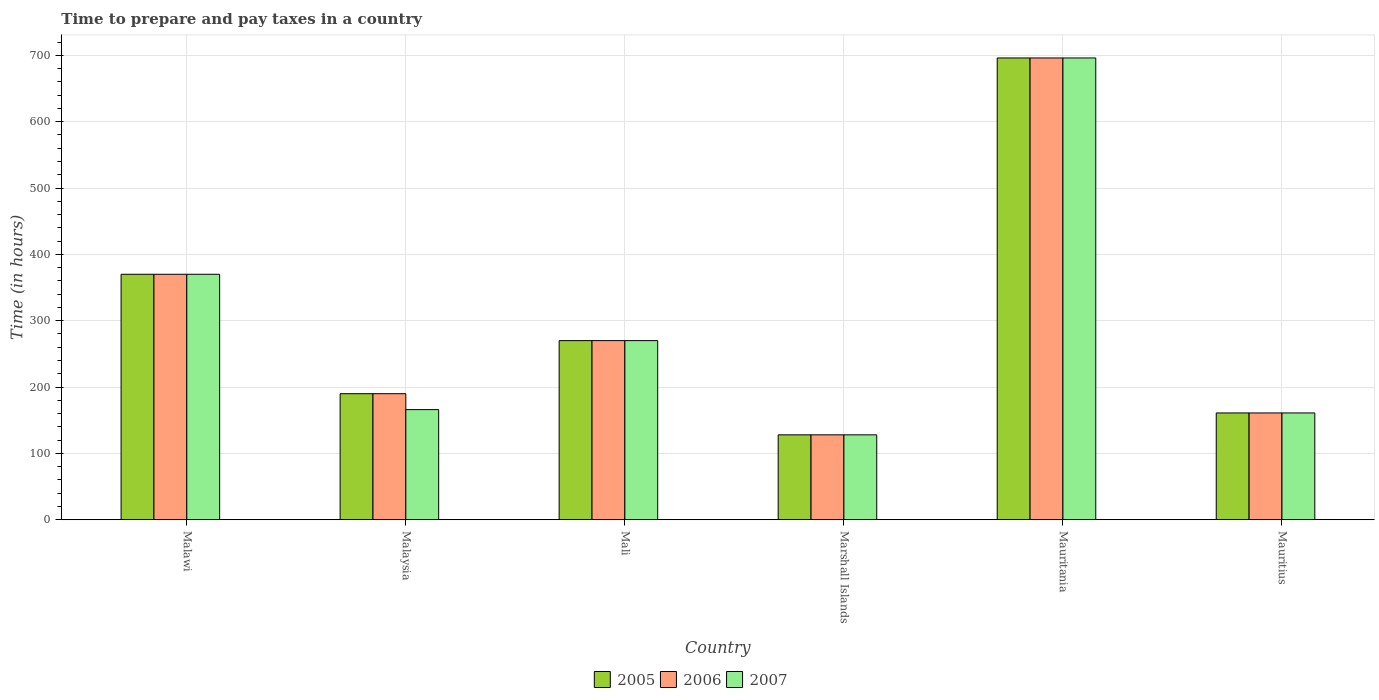How many different coloured bars are there?
Ensure brevity in your answer.  3. Are the number of bars on each tick of the X-axis equal?
Your answer should be compact. Yes. How many bars are there on the 2nd tick from the right?
Make the answer very short. 3. What is the label of the 4th group of bars from the left?
Your response must be concise. Marshall Islands. What is the number of hours required to prepare and pay taxes in 2007 in Mauritania?
Your response must be concise. 696. Across all countries, what is the maximum number of hours required to prepare and pay taxes in 2007?
Offer a very short reply. 696. Across all countries, what is the minimum number of hours required to prepare and pay taxes in 2006?
Provide a succinct answer. 128. In which country was the number of hours required to prepare and pay taxes in 2007 maximum?
Ensure brevity in your answer.  Mauritania. In which country was the number of hours required to prepare and pay taxes in 2007 minimum?
Provide a short and direct response. Marshall Islands. What is the total number of hours required to prepare and pay taxes in 2006 in the graph?
Your response must be concise. 1815. What is the difference between the number of hours required to prepare and pay taxes in 2006 in Malaysia and the number of hours required to prepare and pay taxes in 2007 in Marshall Islands?
Offer a very short reply. 62. What is the average number of hours required to prepare and pay taxes in 2007 per country?
Make the answer very short. 298.5. What is the difference between the number of hours required to prepare and pay taxes of/in 2006 and number of hours required to prepare and pay taxes of/in 2005 in Marshall Islands?
Offer a terse response. 0. In how many countries, is the number of hours required to prepare and pay taxes in 2007 greater than 180 hours?
Offer a terse response. 3. What is the ratio of the number of hours required to prepare and pay taxes in 2006 in Mali to that in Marshall Islands?
Ensure brevity in your answer.  2.11. Is the number of hours required to prepare and pay taxes in 2005 in Malawi less than that in Mali?
Offer a very short reply. No. Is the difference between the number of hours required to prepare and pay taxes in 2006 in Marshall Islands and Mauritius greater than the difference between the number of hours required to prepare and pay taxes in 2005 in Marshall Islands and Mauritius?
Make the answer very short. No. What is the difference between the highest and the second highest number of hours required to prepare and pay taxes in 2005?
Provide a short and direct response. 326. What is the difference between the highest and the lowest number of hours required to prepare and pay taxes in 2007?
Make the answer very short. 568. Is the sum of the number of hours required to prepare and pay taxes in 2007 in Mali and Mauritania greater than the maximum number of hours required to prepare and pay taxes in 2005 across all countries?
Provide a succinct answer. Yes. How many countries are there in the graph?
Ensure brevity in your answer.  6. Does the graph contain grids?
Your answer should be very brief. Yes. How are the legend labels stacked?
Your answer should be very brief. Horizontal. What is the title of the graph?
Your response must be concise. Time to prepare and pay taxes in a country. Does "1984" appear as one of the legend labels in the graph?
Make the answer very short. No. What is the label or title of the X-axis?
Keep it short and to the point. Country. What is the label or title of the Y-axis?
Keep it short and to the point. Time (in hours). What is the Time (in hours) in 2005 in Malawi?
Your answer should be very brief. 370. What is the Time (in hours) in 2006 in Malawi?
Give a very brief answer. 370. What is the Time (in hours) of 2007 in Malawi?
Your answer should be compact. 370. What is the Time (in hours) in 2005 in Malaysia?
Ensure brevity in your answer.  190. What is the Time (in hours) of 2006 in Malaysia?
Ensure brevity in your answer.  190. What is the Time (in hours) in 2007 in Malaysia?
Offer a terse response. 166. What is the Time (in hours) in 2005 in Mali?
Your response must be concise. 270. What is the Time (in hours) of 2006 in Mali?
Your answer should be very brief. 270. What is the Time (in hours) of 2007 in Mali?
Your answer should be compact. 270. What is the Time (in hours) of 2005 in Marshall Islands?
Your answer should be compact. 128. What is the Time (in hours) of 2006 in Marshall Islands?
Give a very brief answer. 128. What is the Time (in hours) in 2007 in Marshall Islands?
Give a very brief answer. 128. What is the Time (in hours) in 2005 in Mauritania?
Make the answer very short. 696. What is the Time (in hours) of 2006 in Mauritania?
Make the answer very short. 696. What is the Time (in hours) of 2007 in Mauritania?
Ensure brevity in your answer.  696. What is the Time (in hours) of 2005 in Mauritius?
Provide a short and direct response. 161. What is the Time (in hours) of 2006 in Mauritius?
Give a very brief answer. 161. What is the Time (in hours) of 2007 in Mauritius?
Provide a succinct answer. 161. Across all countries, what is the maximum Time (in hours) of 2005?
Give a very brief answer. 696. Across all countries, what is the maximum Time (in hours) in 2006?
Ensure brevity in your answer.  696. Across all countries, what is the maximum Time (in hours) of 2007?
Offer a terse response. 696. Across all countries, what is the minimum Time (in hours) of 2005?
Keep it short and to the point. 128. Across all countries, what is the minimum Time (in hours) in 2006?
Keep it short and to the point. 128. Across all countries, what is the minimum Time (in hours) of 2007?
Offer a very short reply. 128. What is the total Time (in hours) of 2005 in the graph?
Your answer should be very brief. 1815. What is the total Time (in hours) of 2006 in the graph?
Your response must be concise. 1815. What is the total Time (in hours) of 2007 in the graph?
Offer a very short reply. 1791. What is the difference between the Time (in hours) in 2005 in Malawi and that in Malaysia?
Your response must be concise. 180. What is the difference between the Time (in hours) of 2006 in Malawi and that in Malaysia?
Provide a short and direct response. 180. What is the difference between the Time (in hours) in 2007 in Malawi and that in Malaysia?
Keep it short and to the point. 204. What is the difference between the Time (in hours) of 2006 in Malawi and that in Mali?
Your response must be concise. 100. What is the difference between the Time (in hours) in 2005 in Malawi and that in Marshall Islands?
Provide a short and direct response. 242. What is the difference between the Time (in hours) of 2006 in Malawi and that in Marshall Islands?
Offer a very short reply. 242. What is the difference between the Time (in hours) of 2007 in Malawi and that in Marshall Islands?
Your answer should be compact. 242. What is the difference between the Time (in hours) of 2005 in Malawi and that in Mauritania?
Your response must be concise. -326. What is the difference between the Time (in hours) in 2006 in Malawi and that in Mauritania?
Provide a succinct answer. -326. What is the difference between the Time (in hours) in 2007 in Malawi and that in Mauritania?
Provide a short and direct response. -326. What is the difference between the Time (in hours) of 2005 in Malawi and that in Mauritius?
Offer a terse response. 209. What is the difference between the Time (in hours) in 2006 in Malawi and that in Mauritius?
Your response must be concise. 209. What is the difference between the Time (in hours) in 2007 in Malawi and that in Mauritius?
Your answer should be very brief. 209. What is the difference between the Time (in hours) of 2005 in Malaysia and that in Mali?
Your answer should be compact. -80. What is the difference between the Time (in hours) of 2006 in Malaysia and that in Mali?
Offer a very short reply. -80. What is the difference between the Time (in hours) in 2007 in Malaysia and that in Mali?
Keep it short and to the point. -104. What is the difference between the Time (in hours) of 2005 in Malaysia and that in Marshall Islands?
Offer a terse response. 62. What is the difference between the Time (in hours) of 2006 in Malaysia and that in Marshall Islands?
Your response must be concise. 62. What is the difference between the Time (in hours) in 2005 in Malaysia and that in Mauritania?
Make the answer very short. -506. What is the difference between the Time (in hours) of 2006 in Malaysia and that in Mauritania?
Provide a succinct answer. -506. What is the difference between the Time (in hours) of 2007 in Malaysia and that in Mauritania?
Provide a short and direct response. -530. What is the difference between the Time (in hours) of 2005 in Malaysia and that in Mauritius?
Make the answer very short. 29. What is the difference between the Time (in hours) in 2005 in Mali and that in Marshall Islands?
Provide a short and direct response. 142. What is the difference between the Time (in hours) of 2006 in Mali and that in Marshall Islands?
Provide a short and direct response. 142. What is the difference between the Time (in hours) in 2007 in Mali and that in Marshall Islands?
Offer a very short reply. 142. What is the difference between the Time (in hours) of 2005 in Mali and that in Mauritania?
Ensure brevity in your answer.  -426. What is the difference between the Time (in hours) in 2006 in Mali and that in Mauritania?
Give a very brief answer. -426. What is the difference between the Time (in hours) of 2007 in Mali and that in Mauritania?
Your answer should be compact. -426. What is the difference between the Time (in hours) in 2005 in Mali and that in Mauritius?
Offer a very short reply. 109. What is the difference between the Time (in hours) of 2006 in Mali and that in Mauritius?
Make the answer very short. 109. What is the difference between the Time (in hours) of 2007 in Mali and that in Mauritius?
Provide a short and direct response. 109. What is the difference between the Time (in hours) of 2005 in Marshall Islands and that in Mauritania?
Your answer should be very brief. -568. What is the difference between the Time (in hours) of 2006 in Marshall Islands and that in Mauritania?
Your answer should be very brief. -568. What is the difference between the Time (in hours) of 2007 in Marshall Islands and that in Mauritania?
Your answer should be very brief. -568. What is the difference between the Time (in hours) of 2005 in Marshall Islands and that in Mauritius?
Keep it short and to the point. -33. What is the difference between the Time (in hours) of 2006 in Marshall Islands and that in Mauritius?
Give a very brief answer. -33. What is the difference between the Time (in hours) of 2007 in Marshall Islands and that in Mauritius?
Provide a short and direct response. -33. What is the difference between the Time (in hours) in 2005 in Mauritania and that in Mauritius?
Offer a terse response. 535. What is the difference between the Time (in hours) of 2006 in Mauritania and that in Mauritius?
Your answer should be very brief. 535. What is the difference between the Time (in hours) in 2007 in Mauritania and that in Mauritius?
Keep it short and to the point. 535. What is the difference between the Time (in hours) of 2005 in Malawi and the Time (in hours) of 2006 in Malaysia?
Keep it short and to the point. 180. What is the difference between the Time (in hours) of 2005 in Malawi and the Time (in hours) of 2007 in Malaysia?
Provide a succinct answer. 204. What is the difference between the Time (in hours) of 2006 in Malawi and the Time (in hours) of 2007 in Malaysia?
Keep it short and to the point. 204. What is the difference between the Time (in hours) of 2005 in Malawi and the Time (in hours) of 2006 in Mali?
Provide a succinct answer. 100. What is the difference between the Time (in hours) of 2005 in Malawi and the Time (in hours) of 2007 in Mali?
Provide a succinct answer. 100. What is the difference between the Time (in hours) in 2006 in Malawi and the Time (in hours) in 2007 in Mali?
Offer a very short reply. 100. What is the difference between the Time (in hours) in 2005 in Malawi and the Time (in hours) in 2006 in Marshall Islands?
Offer a terse response. 242. What is the difference between the Time (in hours) in 2005 in Malawi and the Time (in hours) in 2007 in Marshall Islands?
Your answer should be very brief. 242. What is the difference between the Time (in hours) in 2006 in Malawi and the Time (in hours) in 2007 in Marshall Islands?
Make the answer very short. 242. What is the difference between the Time (in hours) in 2005 in Malawi and the Time (in hours) in 2006 in Mauritania?
Provide a short and direct response. -326. What is the difference between the Time (in hours) in 2005 in Malawi and the Time (in hours) in 2007 in Mauritania?
Keep it short and to the point. -326. What is the difference between the Time (in hours) of 2006 in Malawi and the Time (in hours) of 2007 in Mauritania?
Offer a terse response. -326. What is the difference between the Time (in hours) of 2005 in Malawi and the Time (in hours) of 2006 in Mauritius?
Your answer should be very brief. 209. What is the difference between the Time (in hours) of 2005 in Malawi and the Time (in hours) of 2007 in Mauritius?
Keep it short and to the point. 209. What is the difference between the Time (in hours) of 2006 in Malawi and the Time (in hours) of 2007 in Mauritius?
Provide a succinct answer. 209. What is the difference between the Time (in hours) in 2005 in Malaysia and the Time (in hours) in 2006 in Mali?
Your answer should be compact. -80. What is the difference between the Time (in hours) of 2005 in Malaysia and the Time (in hours) of 2007 in Mali?
Keep it short and to the point. -80. What is the difference between the Time (in hours) of 2006 in Malaysia and the Time (in hours) of 2007 in Mali?
Keep it short and to the point. -80. What is the difference between the Time (in hours) of 2005 in Malaysia and the Time (in hours) of 2007 in Marshall Islands?
Offer a very short reply. 62. What is the difference between the Time (in hours) in 2005 in Malaysia and the Time (in hours) in 2006 in Mauritania?
Offer a terse response. -506. What is the difference between the Time (in hours) of 2005 in Malaysia and the Time (in hours) of 2007 in Mauritania?
Provide a succinct answer. -506. What is the difference between the Time (in hours) in 2006 in Malaysia and the Time (in hours) in 2007 in Mauritania?
Your response must be concise. -506. What is the difference between the Time (in hours) in 2005 in Malaysia and the Time (in hours) in 2006 in Mauritius?
Give a very brief answer. 29. What is the difference between the Time (in hours) of 2006 in Malaysia and the Time (in hours) of 2007 in Mauritius?
Make the answer very short. 29. What is the difference between the Time (in hours) of 2005 in Mali and the Time (in hours) of 2006 in Marshall Islands?
Offer a very short reply. 142. What is the difference between the Time (in hours) of 2005 in Mali and the Time (in hours) of 2007 in Marshall Islands?
Offer a terse response. 142. What is the difference between the Time (in hours) of 2006 in Mali and the Time (in hours) of 2007 in Marshall Islands?
Your response must be concise. 142. What is the difference between the Time (in hours) in 2005 in Mali and the Time (in hours) in 2006 in Mauritania?
Provide a short and direct response. -426. What is the difference between the Time (in hours) of 2005 in Mali and the Time (in hours) of 2007 in Mauritania?
Keep it short and to the point. -426. What is the difference between the Time (in hours) of 2006 in Mali and the Time (in hours) of 2007 in Mauritania?
Your answer should be very brief. -426. What is the difference between the Time (in hours) of 2005 in Mali and the Time (in hours) of 2006 in Mauritius?
Provide a short and direct response. 109. What is the difference between the Time (in hours) of 2005 in Mali and the Time (in hours) of 2007 in Mauritius?
Make the answer very short. 109. What is the difference between the Time (in hours) in 2006 in Mali and the Time (in hours) in 2007 in Mauritius?
Make the answer very short. 109. What is the difference between the Time (in hours) in 2005 in Marshall Islands and the Time (in hours) in 2006 in Mauritania?
Your answer should be very brief. -568. What is the difference between the Time (in hours) of 2005 in Marshall Islands and the Time (in hours) of 2007 in Mauritania?
Give a very brief answer. -568. What is the difference between the Time (in hours) in 2006 in Marshall Islands and the Time (in hours) in 2007 in Mauritania?
Provide a short and direct response. -568. What is the difference between the Time (in hours) in 2005 in Marshall Islands and the Time (in hours) in 2006 in Mauritius?
Make the answer very short. -33. What is the difference between the Time (in hours) in 2005 in Marshall Islands and the Time (in hours) in 2007 in Mauritius?
Offer a very short reply. -33. What is the difference between the Time (in hours) in 2006 in Marshall Islands and the Time (in hours) in 2007 in Mauritius?
Ensure brevity in your answer.  -33. What is the difference between the Time (in hours) of 2005 in Mauritania and the Time (in hours) of 2006 in Mauritius?
Offer a very short reply. 535. What is the difference between the Time (in hours) of 2005 in Mauritania and the Time (in hours) of 2007 in Mauritius?
Provide a succinct answer. 535. What is the difference between the Time (in hours) in 2006 in Mauritania and the Time (in hours) in 2007 in Mauritius?
Your answer should be very brief. 535. What is the average Time (in hours) in 2005 per country?
Provide a short and direct response. 302.5. What is the average Time (in hours) of 2006 per country?
Provide a short and direct response. 302.5. What is the average Time (in hours) in 2007 per country?
Keep it short and to the point. 298.5. What is the difference between the Time (in hours) of 2006 and Time (in hours) of 2007 in Malaysia?
Your response must be concise. 24. What is the difference between the Time (in hours) in 2005 and Time (in hours) in 2006 in Mali?
Your answer should be very brief. 0. What is the difference between the Time (in hours) in 2005 and Time (in hours) in 2007 in Mali?
Make the answer very short. 0. What is the difference between the Time (in hours) in 2005 and Time (in hours) in 2006 in Marshall Islands?
Provide a short and direct response. 0. What is the difference between the Time (in hours) in 2005 and Time (in hours) in 2007 in Marshall Islands?
Keep it short and to the point. 0. What is the difference between the Time (in hours) in 2005 and Time (in hours) in 2006 in Mauritania?
Keep it short and to the point. 0. What is the difference between the Time (in hours) in 2005 and Time (in hours) in 2007 in Mauritius?
Give a very brief answer. 0. What is the ratio of the Time (in hours) of 2005 in Malawi to that in Malaysia?
Offer a terse response. 1.95. What is the ratio of the Time (in hours) of 2006 in Malawi to that in Malaysia?
Offer a very short reply. 1.95. What is the ratio of the Time (in hours) in 2007 in Malawi to that in Malaysia?
Provide a short and direct response. 2.23. What is the ratio of the Time (in hours) of 2005 in Malawi to that in Mali?
Your response must be concise. 1.37. What is the ratio of the Time (in hours) in 2006 in Malawi to that in Mali?
Your answer should be compact. 1.37. What is the ratio of the Time (in hours) in 2007 in Malawi to that in Mali?
Your answer should be compact. 1.37. What is the ratio of the Time (in hours) in 2005 in Malawi to that in Marshall Islands?
Offer a terse response. 2.89. What is the ratio of the Time (in hours) of 2006 in Malawi to that in Marshall Islands?
Your answer should be compact. 2.89. What is the ratio of the Time (in hours) in 2007 in Malawi to that in Marshall Islands?
Your response must be concise. 2.89. What is the ratio of the Time (in hours) of 2005 in Malawi to that in Mauritania?
Your answer should be compact. 0.53. What is the ratio of the Time (in hours) in 2006 in Malawi to that in Mauritania?
Provide a short and direct response. 0.53. What is the ratio of the Time (in hours) in 2007 in Malawi to that in Mauritania?
Ensure brevity in your answer.  0.53. What is the ratio of the Time (in hours) in 2005 in Malawi to that in Mauritius?
Give a very brief answer. 2.3. What is the ratio of the Time (in hours) of 2006 in Malawi to that in Mauritius?
Ensure brevity in your answer.  2.3. What is the ratio of the Time (in hours) in 2007 in Malawi to that in Mauritius?
Your response must be concise. 2.3. What is the ratio of the Time (in hours) in 2005 in Malaysia to that in Mali?
Give a very brief answer. 0.7. What is the ratio of the Time (in hours) of 2006 in Malaysia to that in Mali?
Provide a short and direct response. 0.7. What is the ratio of the Time (in hours) of 2007 in Malaysia to that in Mali?
Make the answer very short. 0.61. What is the ratio of the Time (in hours) of 2005 in Malaysia to that in Marshall Islands?
Provide a succinct answer. 1.48. What is the ratio of the Time (in hours) of 2006 in Malaysia to that in Marshall Islands?
Provide a short and direct response. 1.48. What is the ratio of the Time (in hours) in 2007 in Malaysia to that in Marshall Islands?
Your answer should be compact. 1.3. What is the ratio of the Time (in hours) of 2005 in Malaysia to that in Mauritania?
Offer a very short reply. 0.27. What is the ratio of the Time (in hours) in 2006 in Malaysia to that in Mauritania?
Make the answer very short. 0.27. What is the ratio of the Time (in hours) of 2007 in Malaysia to that in Mauritania?
Offer a terse response. 0.24. What is the ratio of the Time (in hours) of 2005 in Malaysia to that in Mauritius?
Your response must be concise. 1.18. What is the ratio of the Time (in hours) of 2006 in Malaysia to that in Mauritius?
Give a very brief answer. 1.18. What is the ratio of the Time (in hours) in 2007 in Malaysia to that in Mauritius?
Your answer should be very brief. 1.03. What is the ratio of the Time (in hours) in 2005 in Mali to that in Marshall Islands?
Make the answer very short. 2.11. What is the ratio of the Time (in hours) in 2006 in Mali to that in Marshall Islands?
Your answer should be compact. 2.11. What is the ratio of the Time (in hours) of 2007 in Mali to that in Marshall Islands?
Your answer should be compact. 2.11. What is the ratio of the Time (in hours) of 2005 in Mali to that in Mauritania?
Your response must be concise. 0.39. What is the ratio of the Time (in hours) in 2006 in Mali to that in Mauritania?
Provide a succinct answer. 0.39. What is the ratio of the Time (in hours) in 2007 in Mali to that in Mauritania?
Your answer should be very brief. 0.39. What is the ratio of the Time (in hours) in 2005 in Mali to that in Mauritius?
Ensure brevity in your answer.  1.68. What is the ratio of the Time (in hours) of 2006 in Mali to that in Mauritius?
Ensure brevity in your answer.  1.68. What is the ratio of the Time (in hours) in 2007 in Mali to that in Mauritius?
Your answer should be very brief. 1.68. What is the ratio of the Time (in hours) in 2005 in Marshall Islands to that in Mauritania?
Ensure brevity in your answer.  0.18. What is the ratio of the Time (in hours) in 2006 in Marshall Islands to that in Mauritania?
Offer a terse response. 0.18. What is the ratio of the Time (in hours) in 2007 in Marshall Islands to that in Mauritania?
Provide a short and direct response. 0.18. What is the ratio of the Time (in hours) of 2005 in Marshall Islands to that in Mauritius?
Keep it short and to the point. 0.8. What is the ratio of the Time (in hours) in 2006 in Marshall Islands to that in Mauritius?
Your answer should be very brief. 0.8. What is the ratio of the Time (in hours) of 2007 in Marshall Islands to that in Mauritius?
Keep it short and to the point. 0.8. What is the ratio of the Time (in hours) in 2005 in Mauritania to that in Mauritius?
Your response must be concise. 4.32. What is the ratio of the Time (in hours) of 2006 in Mauritania to that in Mauritius?
Offer a terse response. 4.32. What is the ratio of the Time (in hours) of 2007 in Mauritania to that in Mauritius?
Keep it short and to the point. 4.32. What is the difference between the highest and the second highest Time (in hours) in 2005?
Keep it short and to the point. 326. What is the difference between the highest and the second highest Time (in hours) of 2006?
Your answer should be very brief. 326. What is the difference between the highest and the second highest Time (in hours) in 2007?
Offer a terse response. 326. What is the difference between the highest and the lowest Time (in hours) of 2005?
Provide a succinct answer. 568. What is the difference between the highest and the lowest Time (in hours) of 2006?
Provide a short and direct response. 568. What is the difference between the highest and the lowest Time (in hours) in 2007?
Offer a very short reply. 568. 